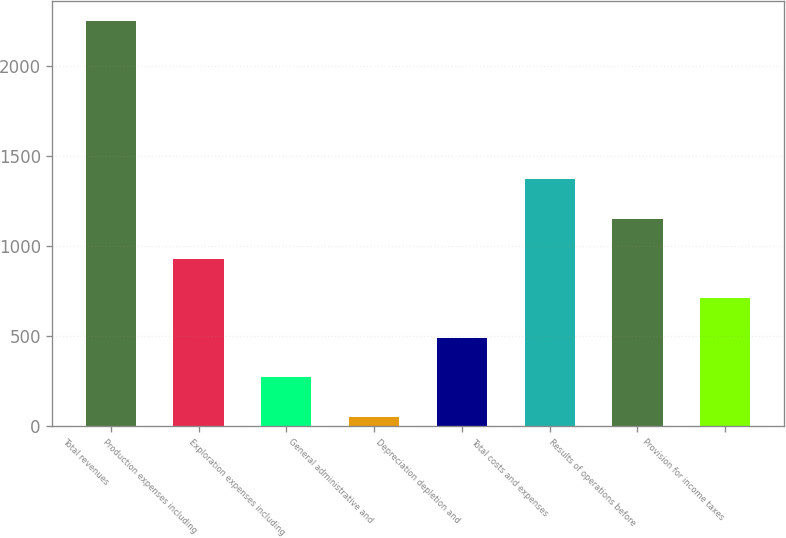Convert chart. <chart><loc_0><loc_0><loc_500><loc_500><bar_chart><fcel>Total revenues<fcel>Production expenses including<fcel>Exploration expenses including<fcel>General administrative and<fcel>Depreciation depletion and<fcel>Total costs and expenses<fcel>Results of operations before<fcel>Provision for income taxes<nl><fcel>2251<fcel>929.2<fcel>268.3<fcel>48<fcel>488.6<fcel>1369.8<fcel>1149.5<fcel>708.9<nl></chart> 